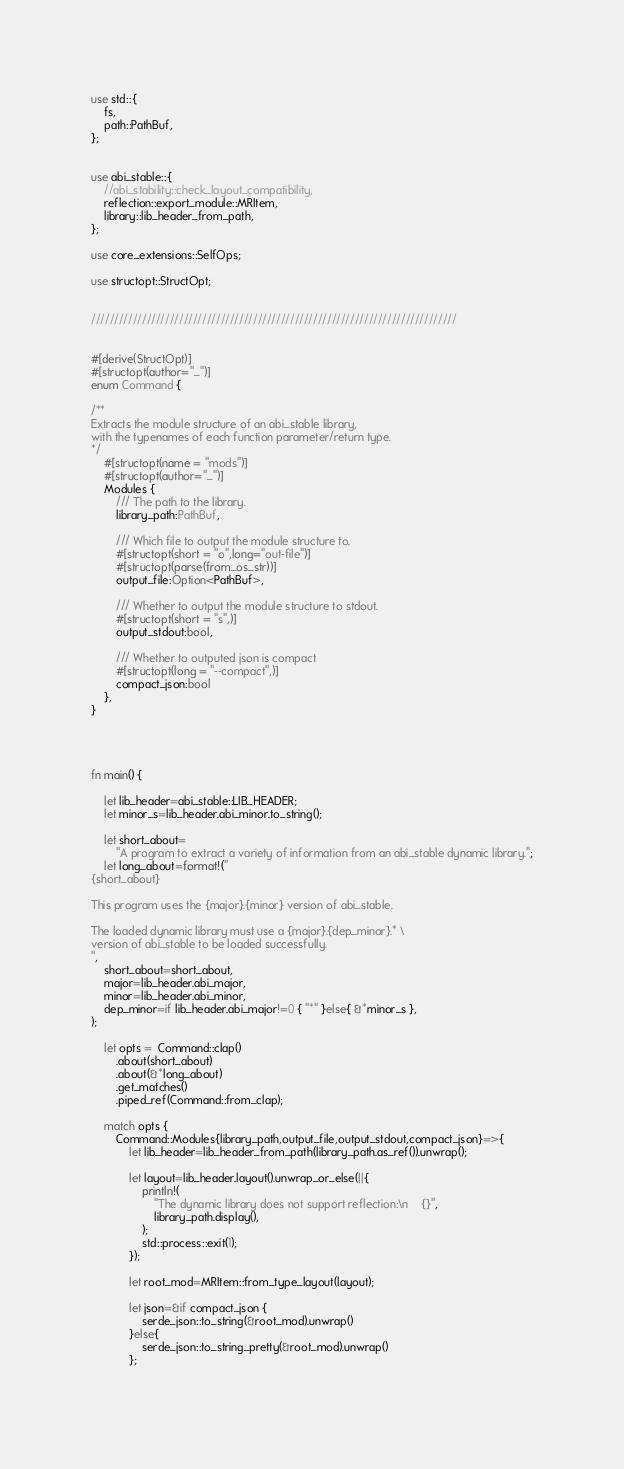Convert code to text. <code><loc_0><loc_0><loc_500><loc_500><_Rust_>use std::{
    fs,
    path::PathBuf,
};


use abi_stable::{
    //abi_stability::check_layout_compatibility,
    reflection::export_module::MRItem,
    library::lib_header_from_path,
};

use core_extensions::SelfOps;

use structopt::StructOpt;


///////////////////////////////////////////////////////////////////////////////


#[derive(StructOpt)]
#[structopt(author="_")]
enum Command {

/**
Extracts the module structure of an abi_stable library,
with the typenames of each function parameter/return type.
*/
    #[structopt(name = "mods")]
    #[structopt(author="_")]
    Modules {
        /// The path to the library.
        library_path:PathBuf,
        
        /// Which file to output the module structure to.
        #[structopt(short = "o",long="out-file")]
        #[structopt(parse(from_os_str))]
        output_file:Option<PathBuf>,
        
        /// Whether to output the module structure to stdout.
        #[structopt(short = "s",)]
        output_stdout:bool,

        /// Whether to outputed json is compact
        #[structopt(long = "--compact",)]
        compact_json:bool
    },
}




fn main() {

    let lib_header=abi_stable::LIB_HEADER;
    let minor_s=lib_header.abi_minor.to_string();

    let short_about=
        "A program to extract a variety of information from an abi_stable dynamic library.";
    let long_about=format!("
{short_about}

This program uses the {major}.{minor} version of abi_stable.

The loaded dynamic library must use a {major}.{dep_minor}.* \
version of abi_stable to be loaded successfully.
",
    short_about=short_about,
    major=lib_header.abi_major,
    minor=lib_header.abi_minor,
    dep_minor=if lib_header.abi_major!=0 { "*" }else{ &*minor_s },
);

    let opts =  Command::clap()
        .about(short_about)
        .about(&*long_about)
        .get_matches()
        .piped_ref(Command::from_clap);

    match opts {
        Command::Modules{library_path,output_file,output_stdout,compact_json}=>{
            let lib_header=lib_header_from_path(library_path.as_ref()).unwrap();

            let layout=lib_header.layout().unwrap_or_else(||{
                println!(
                    "The dynamic library does not support reflection:\n    {}",
                    library_path.display(),
                );
                std::process::exit(1);
            });

            let root_mod=MRItem::from_type_layout(layout);

            let json=&if compact_json {
                serde_json::to_string(&root_mod).unwrap()
            }else{
                serde_json::to_string_pretty(&root_mod).unwrap()
            };
            </code> 